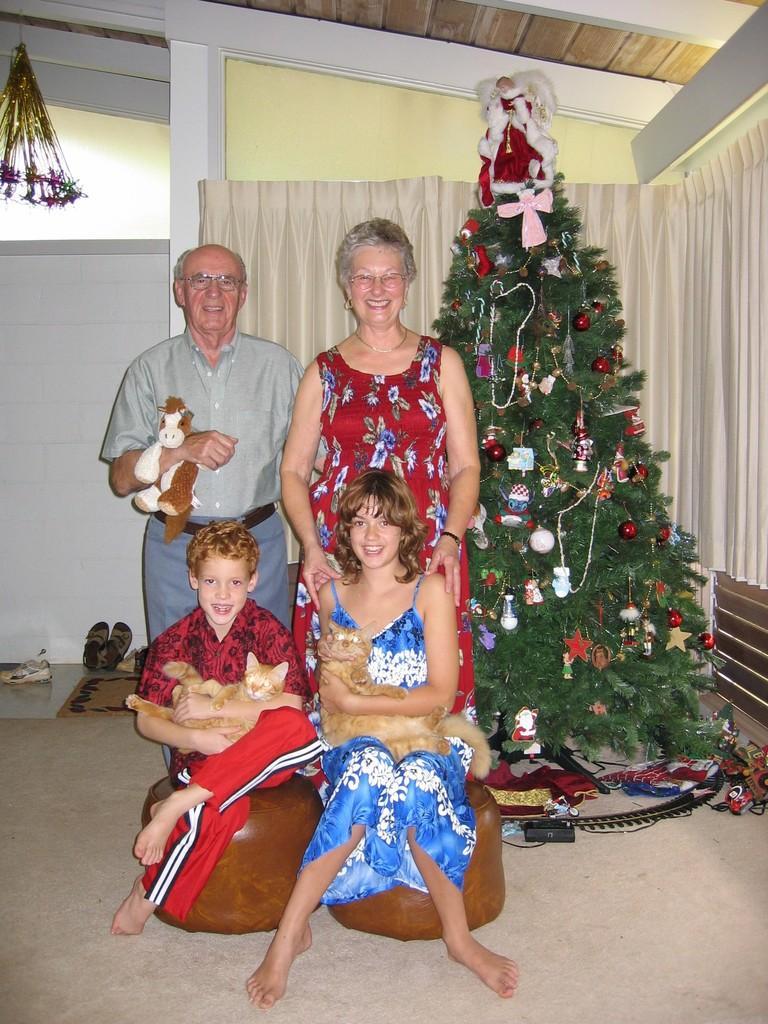Can you describe this image briefly? In this picture I can see there is a man and a woman standing and the man is holding a toy, there is a woman standing next to him, she is smiling and wearing a red dress, there are two kids in front of them, they are holding cats and they are sitting. There is a Christmas tree at right side and there is a wall and a curtain in the backdrop. There are two pairs of footwear at left. 